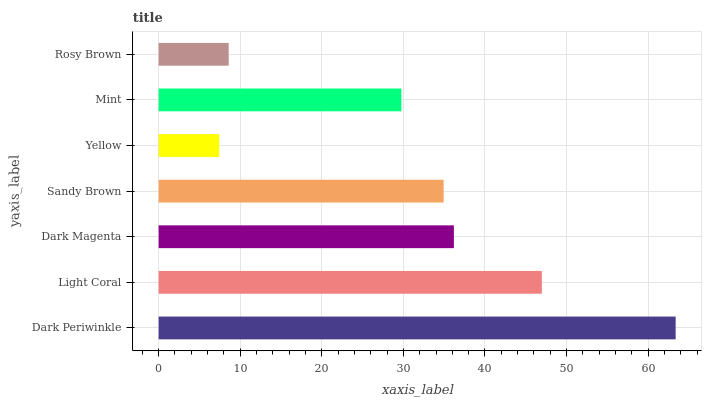Is Yellow the minimum?
Answer yes or no. Yes. Is Dark Periwinkle the maximum?
Answer yes or no. Yes. Is Light Coral the minimum?
Answer yes or no. No. Is Light Coral the maximum?
Answer yes or no. No. Is Dark Periwinkle greater than Light Coral?
Answer yes or no. Yes. Is Light Coral less than Dark Periwinkle?
Answer yes or no. Yes. Is Light Coral greater than Dark Periwinkle?
Answer yes or no. No. Is Dark Periwinkle less than Light Coral?
Answer yes or no. No. Is Sandy Brown the high median?
Answer yes or no. Yes. Is Sandy Brown the low median?
Answer yes or no. Yes. Is Mint the high median?
Answer yes or no. No. Is Yellow the low median?
Answer yes or no. No. 